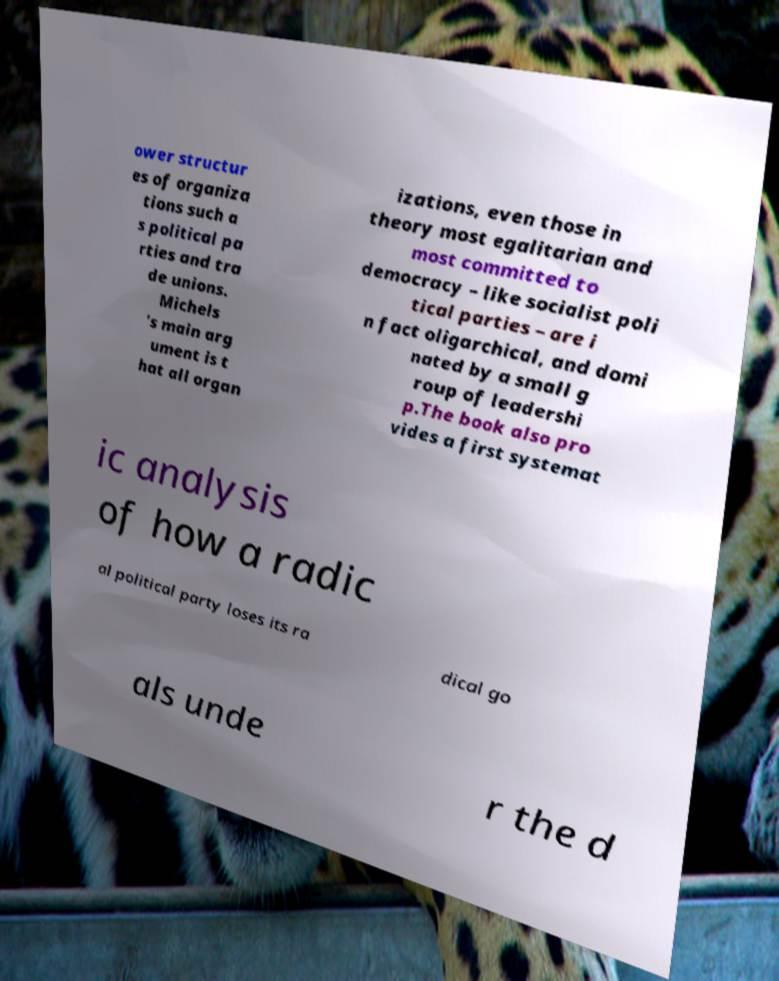There's text embedded in this image that I need extracted. Can you transcribe it verbatim? ower structur es of organiza tions such a s political pa rties and tra de unions. Michels 's main arg ument is t hat all organ izations, even those in theory most egalitarian and most committed to democracy – like socialist poli tical parties – are i n fact oligarchical, and domi nated by a small g roup of leadershi p.The book also pro vides a first systemat ic analysis of how a radic al political party loses its ra dical go als unde r the d 